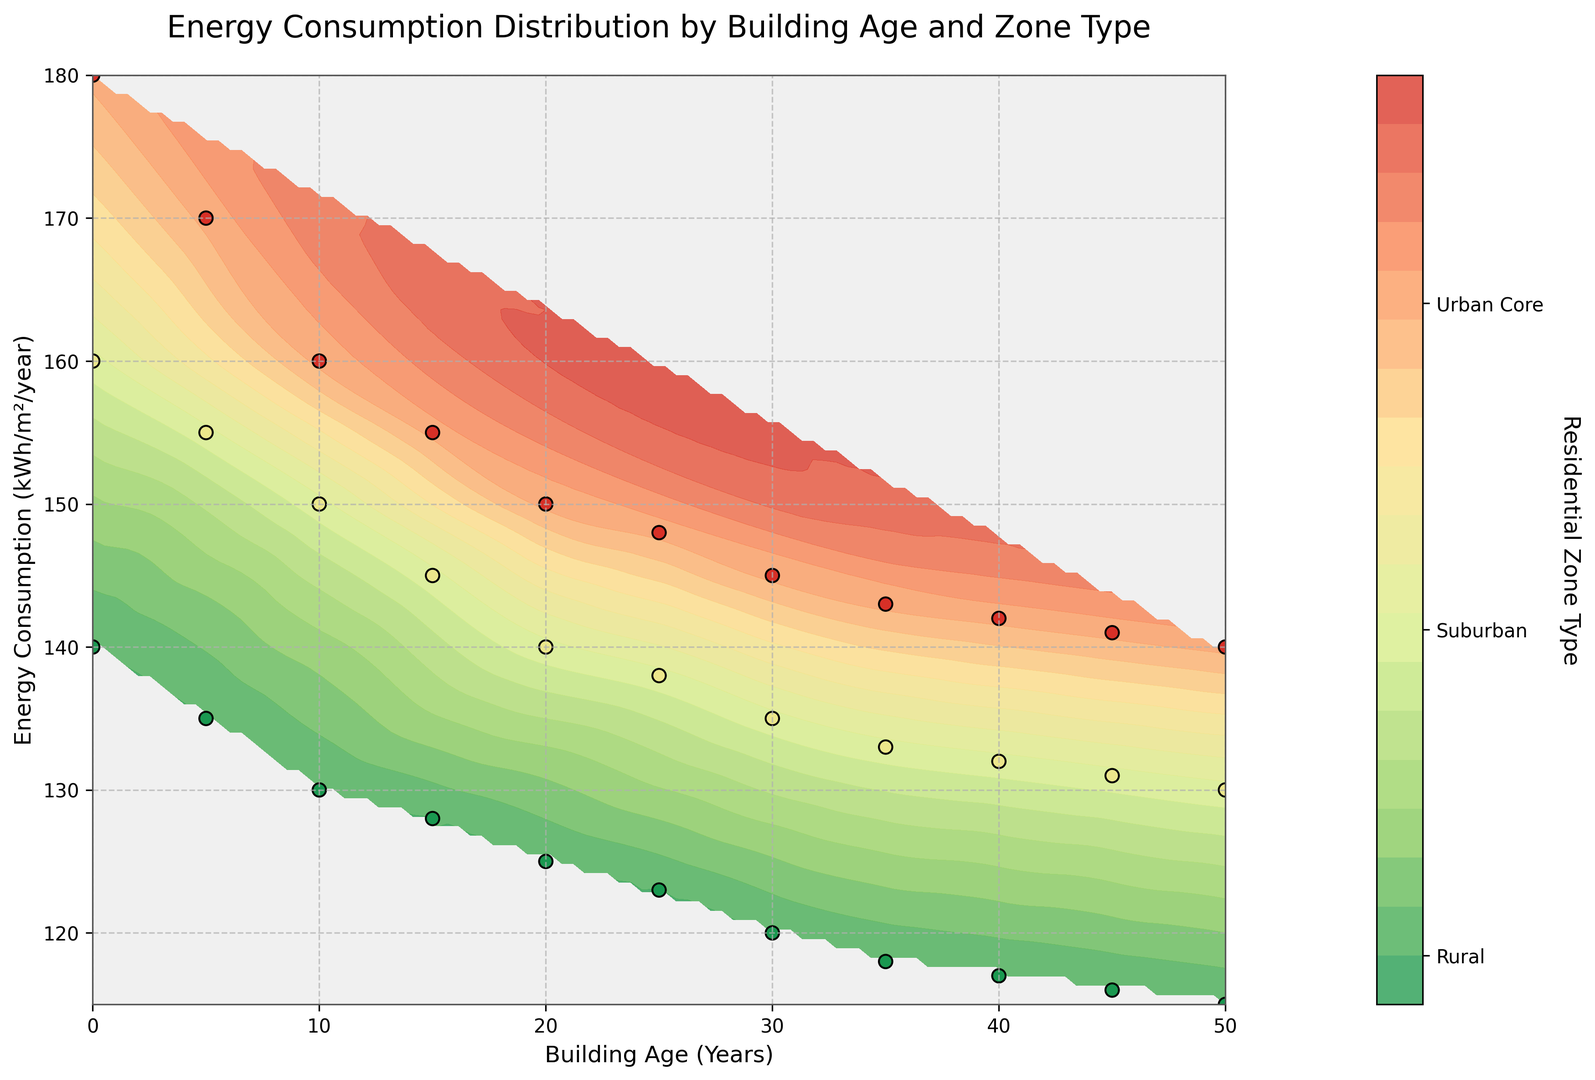What is the energy consumption range for buildings aged 50 years across different zones? To determine the range of energy consumption for buildings aged 50 years, look at the data points along the 50-year mark. The energy consumption in the Urban Core is 140, in the Suburban zone is 130, and in the Rural zone is 115. So, the range extends from 115 to 140.
Answer: 115 to 140 How does energy consumption compare between Urban Core and Rural zones for buildings aged 20 years? For 20-year-old buildings, the Urban Core’s energy consumption is 150, while the Rural zone’s energy consumption is 125. Compare these two values to see that the Urban Core has higher energy consumption by 25.
Answer: 25 more What is the average energy consumption for buildings aged 15 years across all zones? To calculate the average, sum the energy consumption values for 15-year-old buildings: 155 (Urban Core) + 145 (Suburban) + 128 (Rural) = 428. Divide by the number of zones: 428/3 ≈ 143.
Answer: 143 Which zone type has the most distinct color in the region corresponding to the highest energy consumption? The highest energy consumption is observed around the Urban Core zone, which is visually represented by the color corresponding to the Urban Core type. This zone type would dominate the upper part of the plot in terms of color.
Answer: Urban Core As building age increases, what is the general trend in energy consumption for Suburban zones? Observe the contour plot and note how the energy consumption values decrease as the building age increases in Suburban zones. You can see this through the gradient of colors which indicate a decrease in energy consumption as buildings get older.
Answer: Decreases What is the expected energy consumption for a building aged 35 years in a Rural zone? Locate the point corresponding to 35 years in the Rural zone on the plot or from the data table, where the energy consumption value is shown as 118.
Answer: 118 Is the difference in energy consumption between new (0 years) and 30-year-old buildings greater in Urban Core or Suburban zones? For Urban Core: 180 (0 years) - 145 (30 years) = 35. For Suburban: 160 (0 years) - 135 (30 years) = 25. The difference is greater in the Urban Core zone.
Answer: Urban Core How does the color gradient change in the contour plot from new to older buildings in the Rural zones? Look at the color gradient on the contour plot in the Rural zones; it transitions gradually from the color representing higher energy consumption towards the color representing lower energy consumption as buildings get older.
Answer: Gradually decreases What is the steepest decline in energy consumption by age in any zone? Calculate the difference for each zone: Urban Core from 180 to 140 (40 units), Suburban from 160 to 130 (30 units), Rural from 140 to 115 (25 units). The steepest decline by 40 units is found in the Urban Core zone.
Answer: Urban Core What does the contour pattern suggest about the relationship between building age and energy consumption? The contour lines in the plot indicate smooth and gradual changes in energy consumption with building age, suggesting a consistent decrease in energy consumption as building age increases across all zones.
Answer: Decrease with age 